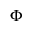Convert formula to latex. <formula><loc_0><loc_0><loc_500><loc_500>\Phi</formula> 